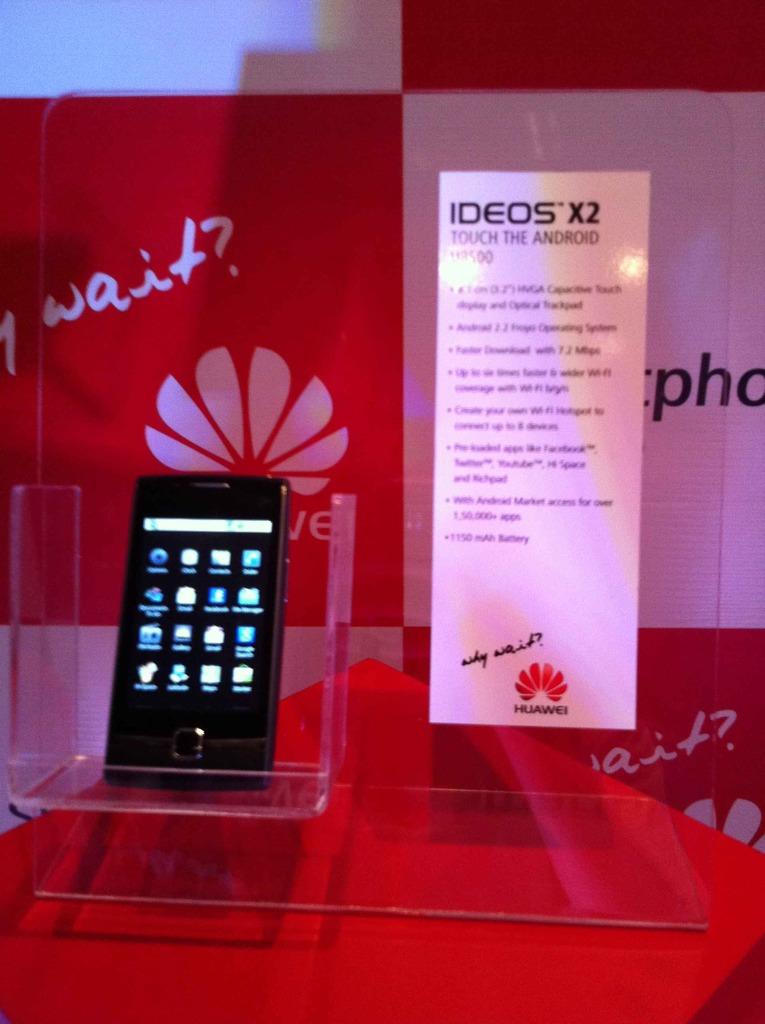Which company is this phone made by?
Provide a short and direct response. Huawei. What model of phone is this?
Your answer should be very brief. Ideos x2. 